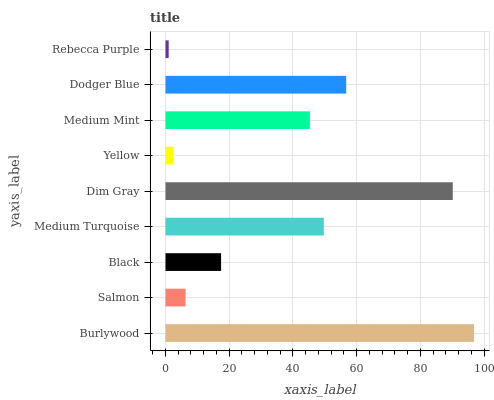Is Rebecca Purple the minimum?
Answer yes or no. Yes. Is Burlywood the maximum?
Answer yes or no. Yes. Is Salmon the minimum?
Answer yes or no. No. Is Salmon the maximum?
Answer yes or no. No. Is Burlywood greater than Salmon?
Answer yes or no. Yes. Is Salmon less than Burlywood?
Answer yes or no. Yes. Is Salmon greater than Burlywood?
Answer yes or no. No. Is Burlywood less than Salmon?
Answer yes or no. No. Is Medium Mint the high median?
Answer yes or no. Yes. Is Medium Mint the low median?
Answer yes or no. Yes. Is Medium Turquoise the high median?
Answer yes or no. No. Is Dim Gray the low median?
Answer yes or no. No. 